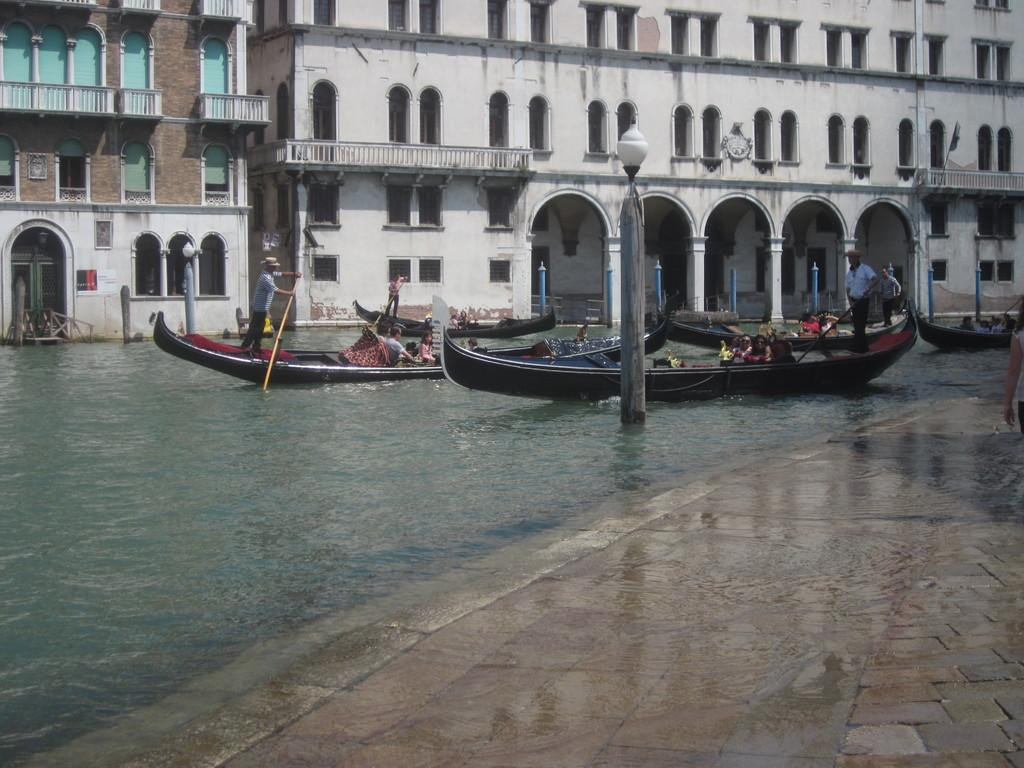How many boats are in the water in the image? There are two boats in the water in the image. Are there any people on the boats? Yes, there are people in one of the boats. What can be seen in the image besides the boats and people? There is a light pole in the image. What can be seen in the background of the image? There are buildings in the background, with white and brown colors. What type of crate is being used as a base for the observation tower in the image? There is no observation tower or crate present in the image. 